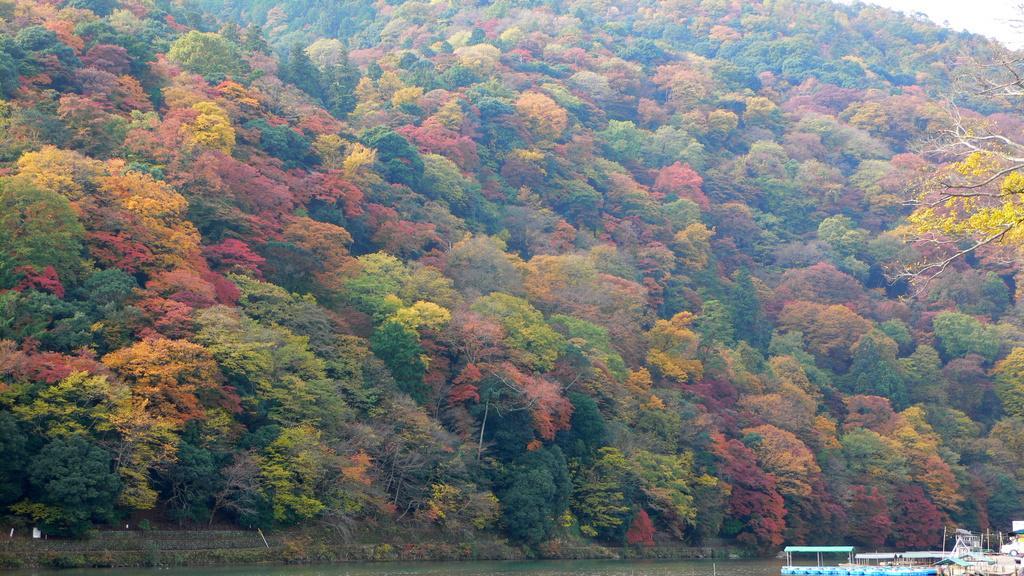How would you summarize this image in a sentence or two? In this image we can see there are so many trees of different color leaves. At the bottom there is water on which there is a boat. On the right side we can see there are yellow flowers. 